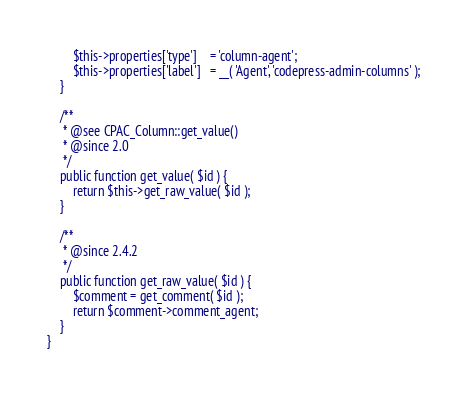<code> <loc_0><loc_0><loc_500><loc_500><_PHP_>		$this->properties['type']	 = 'column-agent';
		$this->properties['label']	 = __( 'Agent', 'codepress-admin-columns' );
	}

	/**
	 * @see CPAC_Column::get_value()
	 * @since 2.0
	 */
	public function get_value( $id ) {
		return $this->get_raw_value( $id );
	}

	/**
	 * @since 2.4.2
	 */
	public function get_raw_value( $id ) {
		$comment = get_comment( $id );
		return $comment->comment_agent;
	}
}</code> 